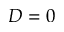Convert formula to latex. <formula><loc_0><loc_0><loc_500><loc_500>D = 0</formula> 